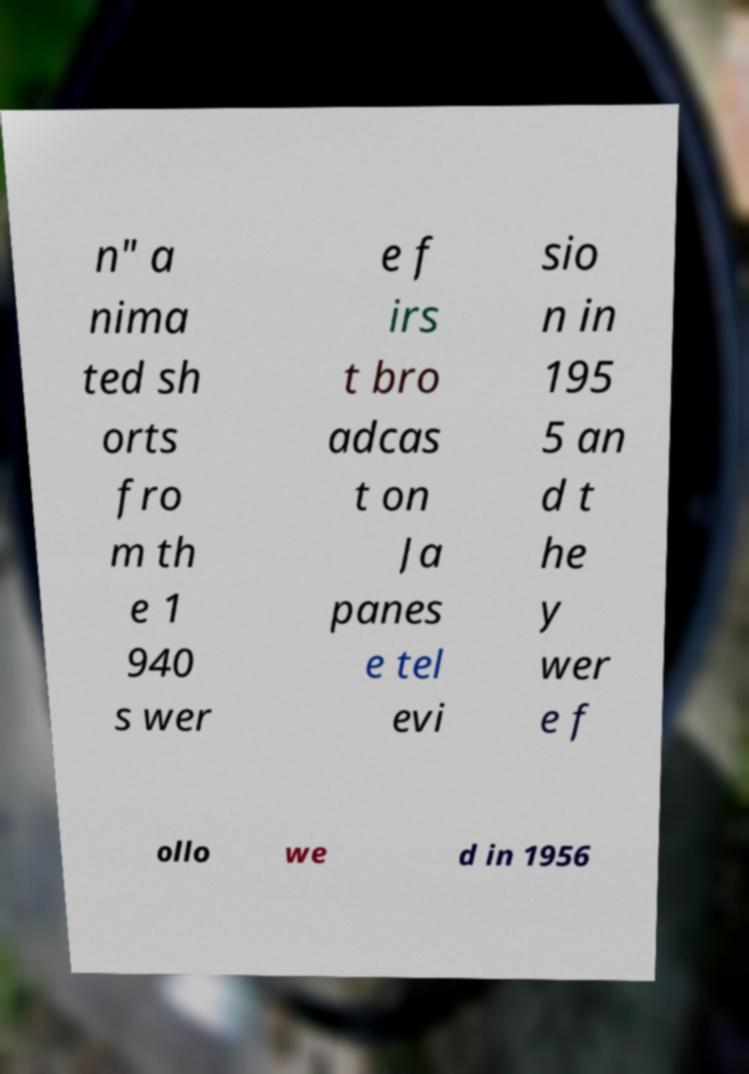Please read and relay the text visible in this image. What does it say? n" a nima ted sh orts fro m th e 1 940 s wer e f irs t bro adcas t on Ja panes e tel evi sio n in 195 5 an d t he y wer e f ollo we d in 1956 